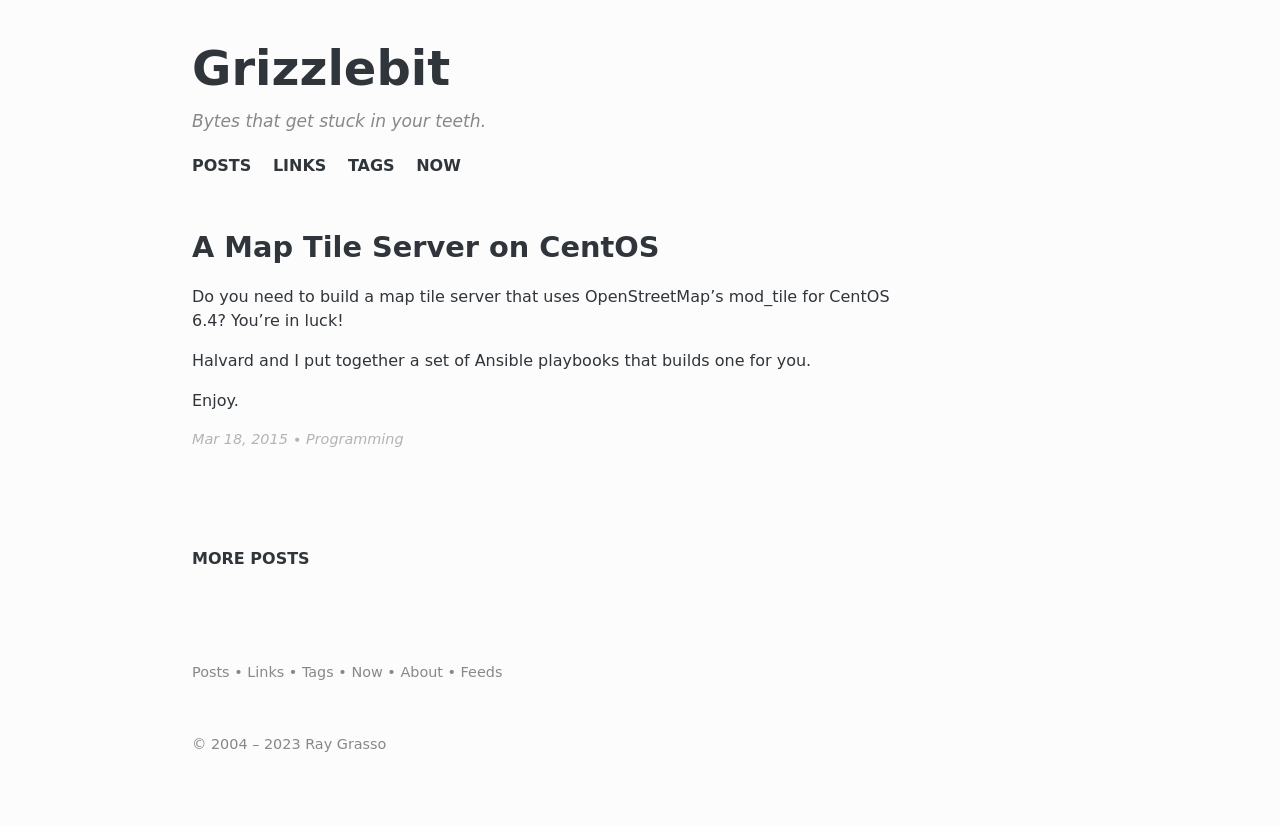Can you explain the significance of the navigation menu on this website? The navigation menu is crucial as it guides visitors through the website's structure, providing quick access to different sections like Posts, Links, Tags, and Now. It's designed to enhance user experience by making the site's content easily discoverable and ensuring a clutter-free layout that doesn't overwhelm users. A well-organized navigation menu can significantly improve the usability of a website.  What improvements could be made to this footer? The footer could be improved by including more descriptive link text for better accessibility, potentially adding a short 'About' description to foster user connection, and perhaps integrating social media icons for a modern touch. Additionally, ensuring clear visibility and functionality across devices would further optimize the footer. 